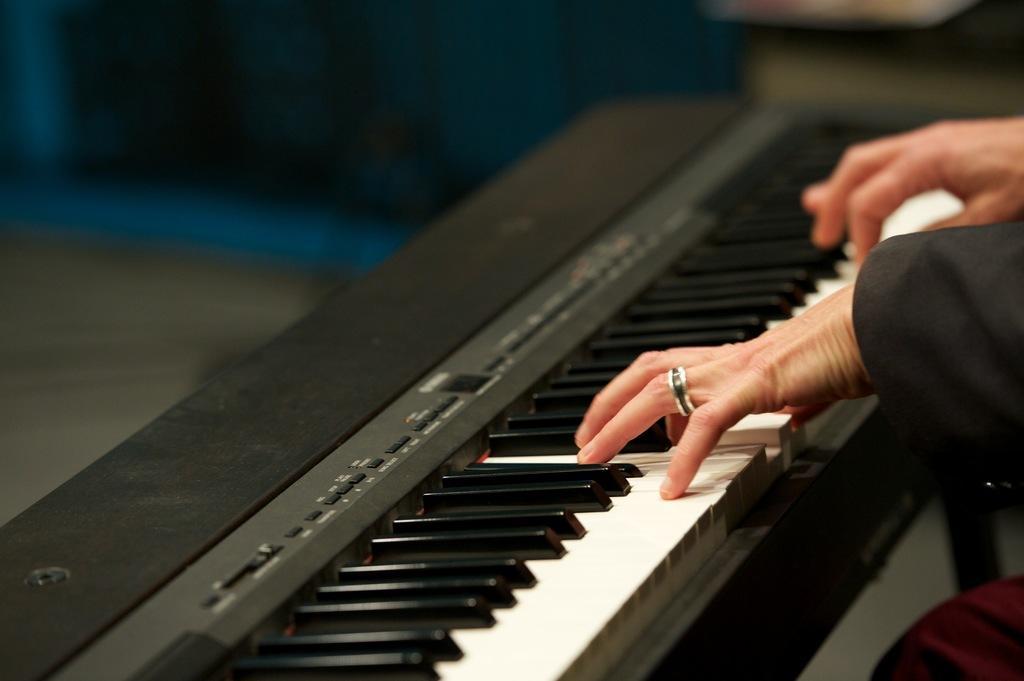Could you give a brief overview of what you see in this image? In this picture there is a person playing piano. In this piano, there are white and black keys on it. 